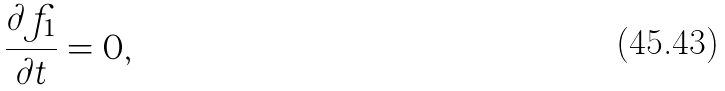<formula> <loc_0><loc_0><loc_500><loc_500>\frac { \partial f _ { 1 } } { \partial t } = 0 ,</formula> 